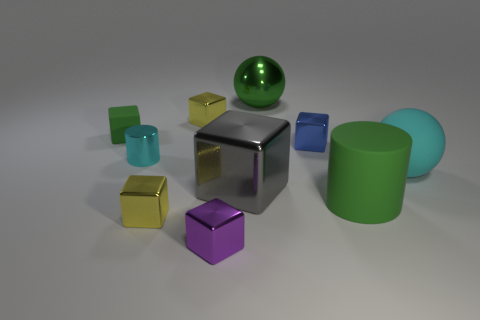Subtract 1 blocks. How many blocks are left? 5 Subtract all purple cubes. How many cubes are left? 5 Subtract all big blocks. How many blocks are left? 5 Subtract all red cubes. Subtract all cyan cylinders. How many cubes are left? 6 Subtract all blocks. How many objects are left? 4 Add 9 big cyan matte objects. How many big cyan matte objects exist? 10 Subtract 1 cyan cylinders. How many objects are left? 9 Subtract all small cyan shiny things. Subtract all blue cubes. How many objects are left? 8 Add 8 small cyan metallic things. How many small cyan metallic things are left? 9 